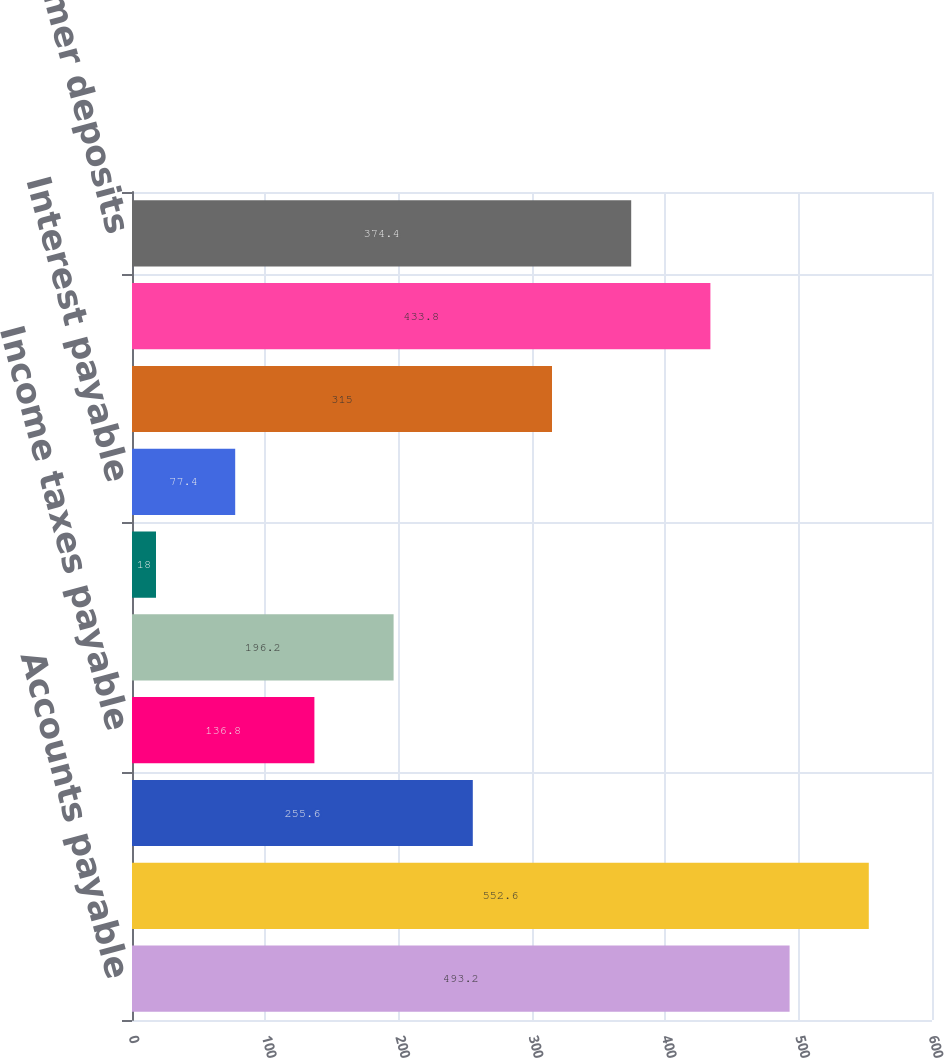<chart> <loc_0><loc_0><loc_500><loc_500><bar_chart><fcel>Accounts payable<fcel>Compensation and employee<fcel>Warranty<fcel>Income taxes payable<fcel>Dividends payable<fcel>Other accrued taxes<fcel>Interest payable<fcel>Restructuring reserve<fcel>Other<fcel>Customer deposits<nl><fcel>493.2<fcel>552.6<fcel>255.6<fcel>136.8<fcel>196.2<fcel>18<fcel>77.4<fcel>315<fcel>433.8<fcel>374.4<nl></chart> 